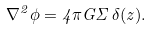<formula> <loc_0><loc_0><loc_500><loc_500>\nabla ^ { 2 } \phi = 4 \pi G \Sigma \, \delta ( z ) .</formula> 